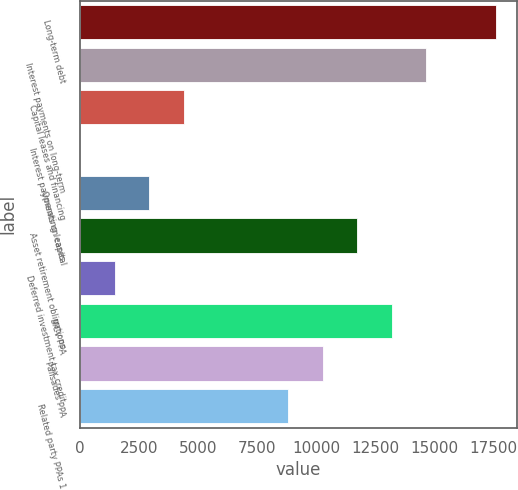Convert chart. <chart><loc_0><loc_0><loc_500><loc_500><bar_chart><fcel>Long-term debt<fcel>Interest payments on long-term<fcel>Capital leases and financing<fcel>Interest payments on capital<fcel>Operating leases<fcel>Asset retirement obligations<fcel>Deferred investment tax credit<fcel>MCV PPA<fcel>Palisades PPA<fcel>Related party PPAs 1<nl><fcel>17616.6<fcel>14683<fcel>4415.4<fcel>15<fcel>2948.6<fcel>11749.4<fcel>1481.8<fcel>13216.2<fcel>10282.6<fcel>8815.8<nl></chart> 